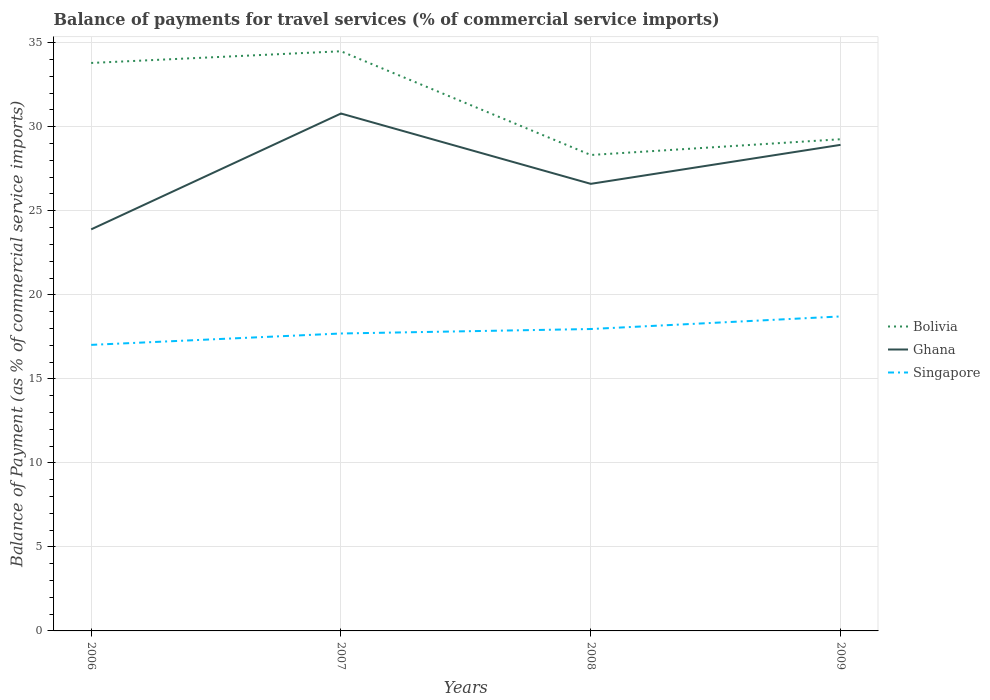Across all years, what is the maximum balance of payments for travel services in Bolivia?
Your answer should be very brief. 28.32. What is the total balance of payments for travel services in Bolivia in the graph?
Give a very brief answer. -0.7. What is the difference between the highest and the second highest balance of payments for travel services in Ghana?
Your answer should be compact. 6.89. What is the difference between the highest and the lowest balance of payments for travel services in Singapore?
Provide a succinct answer. 2. How many lines are there?
Ensure brevity in your answer.  3. Are the values on the major ticks of Y-axis written in scientific E-notation?
Ensure brevity in your answer.  No. Does the graph contain grids?
Your answer should be very brief. Yes. What is the title of the graph?
Your answer should be very brief. Balance of payments for travel services (% of commercial service imports). What is the label or title of the Y-axis?
Keep it short and to the point. Balance of Payment (as % of commercial service imports). What is the Balance of Payment (as % of commercial service imports) of Bolivia in 2006?
Provide a succinct answer. 33.8. What is the Balance of Payment (as % of commercial service imports) of Ghana in 2006?
Offer a very short reply. 23.89. What is the Balance of Payment (as % of commercial service imports) of Singapore in 2006?
Offer a terse response. 17.02. What is the Balance of Payment (as % of commercial service imports) of Bolivia in 2007?
Your answer should be very brief. 34.49. What is the Balance of Payment (as % of commercial service imports) in Ghana in 2007?
Make the answer very short. 30.79. What is the Balance of Payment (as % of commercial service imports) in Singapore in 2007?
Offer a very short reply. 17.7. What is the Balance of Payment (as % of commercial service imports) in Bolivia in 2008?
Provide a short and direct response. 28.32. What is the Balance of Payment (as % of commercial service imports) in Ghana in 2008?
Ensure brevity in your answer.  26.6. What is the Balance of Payment (as % of commercial service imports) in Singapore in 2008?
Offer a very short reply. 17.96. What is the Balance of Payment (as % of commercial service imports) of Bolivia in 2009?
Ensure brevity in your answer.  29.26. What is the Balance of Payment (as % of commercial service imports) in Ghana in 2009?
Provide a short and direct response. 28.92. What is the Balance of Payment (as % of commercial service imports) in Singapore in 2009?
Your response must be concise. 18.71. Across all years, what is the maximum Balance of Payment (as % of commercial service imports) of Bolivia?
Give a very brief answer. 34.49. Across all years, what is the maximum Balance of Payment (as % of commercial service imports) in Ghana?
Ensure brevity in your answer.  30.79. Across all years, what is the maximum Balance of Payment (as % of commercial service imports) in Singapore?
Your response must be concise. 18.71. Across all years, what is the minimum Balance of Payment (as % of commercial service imports) of Bolivia?
Provide a short and direct response. 28.32. Across all years, what is the minimum Balance of Payment (as % of commercial service imports) of Ghana?
Make the answer very short. 23.89. Across all years, what is the minimum Balance of Payment (as % of commercial service imports) of Singapore?
Your response must be concise. 17.02. What is the total Balance of Payment (as % of commercial service imports) of Bolivia in the graph?
Your response must be concise. 125.87. What is the total Balance of Payment (as % of commercial service imports) in Ghana in the graph?
Offer a terse response. 110.21. What is the total Balance of Payment (as % of commercial service imports) of Singapore in the graph?
Make the answer very short. 71.4. What is the difference between the Balance of Payment (as % of commercial service imports) in Bolivia in 2006 and that in 2007?
Give a very brief answer. -0.7. What is the difference between the Balance of Payment (as % of commercial service imports) of Ghana in 2006 and that in 2007?
Make the answer very short. -6.89. What is the difference between the Balance of Payment (as % of commercial service imports) of Singapore in 2006 and that in 2007?
Make the answer very short. -0.68. What is the difference between the Balance of Payment (as % of commercial service imports) in Bolivia in 2006 and that in 2008?
Ensure brevity in your answer.  5.48. What is the difference between the Balance of Payment (as % of commercial service imports) of Ghana in 2006 and that in 2008?
Make the answer very short. -2.71. What is the difference between the Balance of Payment (as % of commercial service imports) in Singapore in 2006 and that in 2008?
Make the answer very short. -0.94. What is the difference between the Balance of Payment (as % of commercial service imports) in Bolivia in 2006 and that in 2009?
Your response must be concise. 4.54. What is the difference between the Balance of Payment (as % of commercial service imports) of Ghana in 2006 and that in 2009?
Offer a terse response. -5.03. What is the difference between the Balance of Payment (as % of commercial service imports) in Singapore in 2006 and that in 2009?
Your response must be concise. -1.69. What is the difference between the Balance of Payment (as % of commercial service imports) in Bolivia in 2007 and that in 2008?
Offer a terse response. 6.17. What is the difference between the Balance of Payment (as % of commercial service imports) in Ghana in 2007 and that in 2008?
Keep it short and to the point. 4.18. What is the difference between the Balance of Payment (as % of commercial service imports) in Singapore in 2007 and that in 2008?
Your response must be concise. -0.27. What is the difference between the Balance of Payment (as % of commercial service imports) of Bolivia in 2007 and that in 2009?
Your answer should be compact. 5.24. What is the difference between the Balance of Payment (as % of commercial service imports) in Ghana in 2007 and that in 2009?
Provide a short and direct response. 1.87. What is the difference between the Balance of Payment (as % of commercial service imports) of Singapore in 2007 and that in 2009?
Ensure brevity in your answer.  -1.01. What is the difference between the Balance of Payment (as % of commercial service imports) in Bolivia in 2008 and that in 2009?
Ensure brevity in your answer.  -0.94. What is the difference between the Balance of Payment (as % of commercial service imports) of Ghana in 2008 and that in 2009?
Offer a terse response. -2.32. What is the difference between the Balance of Payment (as % of commercial service imports) in Singapore in 2008 and that in 2009?
Make the answer very short. -0.75. What is the difference between the Balance of Payment (as % of commercial service imports) of Bolivia in 2006 and the Balance of Payment (as % of commercial service imports) of Ghana in 2007?
Offer a terse response. 3.01. What is the difference between the Balance of Payment (as % of commercial service imports) in Bolivia in 2006 and the Balance of Payment (as % of commercial service imports) in Singapore in 2007?
Your answer should be compact. 16.1. What is the difference between the Balance of Payment (as % of commercial service imports) of Ghana in 2006 and the Balance of Payment (as % of commercial service imports) of Singapore in 2007?
Provide a succinct answer. 6.2. What is the difference between the Balance of Payment (as % of commercial service imports) in Bolivia in 2006 and the Balance of Payment (as % of commercial service imports) in Ghana in 2008?
Your response must be concise. 7.19. What is the difference between the Balance of Payment (as % of commercial service imports) in Bolivia in 2006 and the Balance of Payment (as % of commercial service imports) in Singapore in 2008?
Make the answer very short. 15.83. What is the difference between the Balance of Payment (as % of commercial service imports) of Ghana in 2006 and the Balance of Payment (as % of commercial service imports) of Singapore in 2008?
Ensure brevity in your answer.  5.93. What is the difference between the Balance of Payment (as % of commercial service imports) in Bolivia in 2006 and the Balance of Payment (as % of commercial service imports) in Ghana in 2009?
Give a very brief answer. 4.87. What is the difference between the Balance of Payment (as % of commercial service imports) of Bolivia in 2006 and the Balance of Payment (as % of commercial service imports) of Singapore in 2009?
Offer a very short reply. 15.08. What is the difference between the Balance of Payment (as % of commercial service imports) in Ghana in 2006 and the Balance of Payment (as % of commercial service imports) in Singapore in 2009?
Provide a short and direct response. 5.18. What is the difference between the Balance of Payment (as % of commercial service imports) in Bolivia in 2007 and the Balance of Payment (as % of commercial service imports) in Ghana in 2008?
Provide a succinct answer. 7.89. What is the difference between the Balance of Payment (as % of commercial service imports) in Bolivia in 2007 and the Balance of Payment (as % of commercial service imports) in Singapore in 2008?
Your answer should be compact. 16.53. What is the difference between the Balance of Payment (as % of commercial service imports) of Ghana in 2007 and the Balance of Payment (as % of commercial service imports) of Singapore in 2008?
Your response must be concise. 12.82. What is the difference between the Balance of Payment (as % of commercial service imports) of Bolivia in 2007 and the Balance of Payment (as % of commercial service imports) of Ghana in 2009?
Ensure brevity in your answer.  5.57. What is the difference between the Balance of Payment (as % of commercial service imports) of Bolivia in 2007 and the Balance of Payment (as % of commercial service imports) of Singapore in 2009?
Make the answer very short. 15.78. What is the difference between the Balance of Payment (as % of commercial service imports) of Ghana in 2007 and the Balance of Payment (as % of commercial service imports) of Singapore in 2009?
Your response must be concise. 12.08. What is the difference between the Balance of Payment (as % of commercial service imports) in Bolivia in 2008 and the Balance of Payment (as % of commercial service imports) in Ghana in 2009?
Give a very brief answer. -0.6. What is the difference between the Balance of Payment (as % of commercial service imports) in Bolivia in 2008 and the Balance of Payment (as % of commercial service imports) in Singapore in 2009?
Make the answer very short. 9.61. What is the difference between the Balance of Payment (as % of commercial service imports) of Ghana in 2008 and the Balance of Payment (as % of commercial service imports) of Singapore in 2009?
Ensure brevity in your answer.  7.89. What is the average Balance of Payment (as % of commercial service imports) in Bolivia per year?
Offer a very short reply. 31.47. What is the average Balance of Payment (as % of commercial service imports) in Ghana per year?
Keep it short and to the point. 27.55. What is the average Balance of Payment (as % of commercial service imports) of Singapore per year?
Provide a short and direct response. 17.85. In the year 2006, what is the difference between the Balance of Payment (as % of commercial service imports) of Bolivia and Balance of Payment (as % of commercial service imports) of Ghana?
Keep it short and to the point. 9.9. In the year 2006, what is the difference between the Balance of Payment (as % of commercial service imports) in Bolivia and Balance of Payment (as % of commercial service imports) in Singapore?
Your answer should be very brief. 16.78. In the year 2006, what is the difference between the Balance of Payment (as % of commercial service imports) in Ghana and Balance of Payment (as % of commercial service imports) in Singapore?
Provide a short and direct response. 6.87. In the year 2007, what is the difference between the Balance of Payment (as % of commercial service imports) in Bolivia and Balance of Payment (as % of commercial service imports) in Ghana?
Offer a terse response. 3.7. In the year 2007, what is the difference between the Balance of Payment (as % of commercial service imports) of Bolivia and Balance of Payment (as % of commercial service imports) of Singapore?
Provide a short and direct response. 16.79. In the year 2007, what is the difference between the Balance of Payment (as % of commercial service imports) in Ghana and Balance of Payment (as % of commercial service imports) in Singapore?
Ensure brevity in your answer.  13.09. In the year 2008, what is the difference between the Balance of Payment (as % of commercial service imports) in Bolivia and Balance of Payment (as % of commercial service imports) in Ghana?
Provide a succinct answer. 1.72. In the year 2008, what is the difference between the Balance of Payment (as % of commercial service imports) of Bolivia and Balance of Payment (as % of commercial service imports) of Singapore?
Give a very brief answer. 10.36. In the year 2008, what is the difference between the Balance of Payment (as % of commercial service imports) in Ghana and Balance of Payment (as % of commercial service imports) in Singapore?
Offer a very short reply. 8.64. In the year 2009, what is the difference between the Balance of Payment (as % of commercial service imports) of Bolivia and Balance of Payment (as % of commercial service imports) of Ghana?
Offer a very short reply. 0.33. In the year 2009, what is the difference between the Balance of Payment (as % of commercial service imports) in Bolivia and Balance of Payment (as % of commercial service imports) in Singapore?
Offer a very short reply. 10.54. In the year 2009, what is the difference between the Balance of Payment (as % of commercial service imports) in Ghana and Balance of Payment (as % of commercial service imports) in Singapore?
Keep it short and to the point. 10.21. What is the ratio of the Balance of Payment (as % of commercial service imports) in Bolivia in 2006 to that in 2007?
Your answer should be very brief. 0.98. What is the ratio of the Balance of Payment (as % of commercial service imports) of Ghana in 2006 to that in 2007?
Your answer should be very brief. 0.78. What is the ratio of the Balance of Payment (as % of commercial service imports) in Singapore in 2006 to that in 2007?
Make the answer very short. 0.96. What is the ratio of the Balance of Payment (as % of commercial service imports) of Bolivia in 2006 to that in 2008?
Give a very brief answer. 1.19. What is the ratio of the Balance of Payment (as % of commercial service imports) of Ghana in 2006 to that in 2008?
Provide a short and direct response. 0.9. What is the ratio of the Balance of Payment (as % of commercial service imports) in Singapore in 2006 to that in 2008?
Give a very brief answer. 0.95. What is the ratio of the Balance of Payment (as % of commercial service imports) in Bolivia in 2006 to that in 2009?
Your answer should be very brief. 1.16. What is the ratio of the Balance of Payment (as % of commercial service imports) in Ghana in 2006 to that in 2009?
Your answer should be compact. 0.83. What is the ratio of the Balance of Payment (as % of commercial service imports) in Singapore in 2006 to that in 2009?
Keep it short and to the point. 0.91. What is the ratio of the Balance of Payment (as % of commercial service imports) in Bolivia in 2007 to that in 2008?
Provide a succinct answer. 1.22. What is the ratio of the Balance of Payment (as % of commercial service imports) of Ghana in 2007 to that in 2008?
Provide a short and direct response. 1.16. What is the ratio of the Balance of Payment (as % of commercial service imports) in Singapore in 2007 to that in 2008?
Offer a very short reply. 0.99. What is the ratio of the Balance of Payment (as % of commercial service imports) of Bolivia in 2007 to that in 2009?
Give a very brief answer. 1.18. What is the ratio of the Balance of Payment (as % of commercial service imports) in Ghana in 2007 to that in 2009?
Offer a terse response. 1.06. What is the ratio of the Balance of Payment (as % of commercial service imports) of Singapore in 2007 to that in 2009?
Your answer should be compact. 0.95. What is the ratio of the Balance of Payment (as % of commercial service imports) in Bolivia in 2008 to that in 2009?
Your answer should be very brief. 0.97. What is the ratio of the Balance of Payment (as % of commercial service imports) in Ghana in 2008 to that in 2009?
Make the answer very short. 0.92. What is the difference between the highest and the second highest Balance of Payment (as % of commercial service imports) in Bolivia?
Offer a terse response. 0.7. What is the difference between the highest and the second highest Balance of Payment (as % of commercial service imports) in Ghana?
Make the answer very short. 1.87. What is the difference between the highest and the second highest Balance of Payment (as % of commercial service imports) of Singapore?
Keep it short and to the point. 0.75. What is the difference between the highest and the lowest Balance of Payment (as % of commercial service imports) of Bolivia?
Keep it short and to the point. 6.17. What is the difference between the highest and the lowest Balance of Payment (as % of commercial service imports) in Ghana?
Keep it short and to the point. 6.89. What is the difference between the highest and the lowest Balance of Payment (as % of commercial service imports) in Singapore?
Make the answer very short. 1.69. 